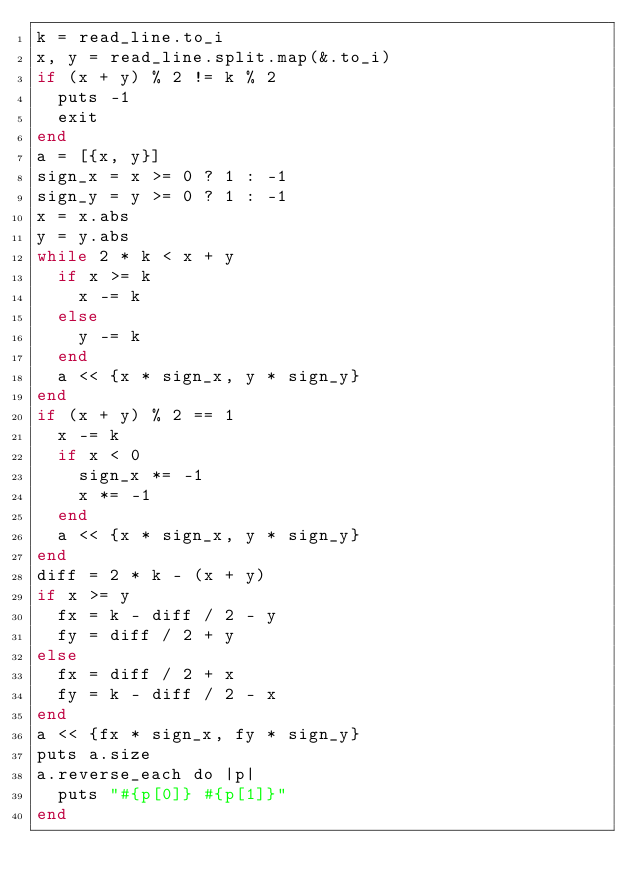<code> <loc_0><loc_0><loc_500><loc_500><_Crystal_>k = read_line.to_i
x, y = read_line.split.map(&.to_i)
if (x + y) % 2 != k % 2
  puts -1
  exit
end
a = [{x, y}]
sign_x = x >= 0 ? 1 : -1
sign_y = y >= 0 ? 1 : -1
x = x.abs
y = y.abs
while 2 * k < x + y
  if x >= k
    x -= k
  else
    y -= k
  end
  a << {x * sign_x, y * sign_y}
end
if (x + y) % 2 == 1
  x -= k
  if x < 0
    sign_x *= -1
    x *= -1
  end
  a << {x * sign_x, y * sign_y}
end
diff = 2 * k - (x + y)
if x >= y
  fx = k - diff / 2 - y
  fy = diff / 2 + y
else
  fx = diff / 2 + x
  fy = k - diff / 2 - x
end
a << {fx * sign_x, fy * sign_y}
puts a.size
a.reverse_each do |p|
  puts "#{p[0]} #{p[1]}"
end
</code> 